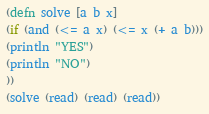<code> <loc_0><loc_0><loc_500><loc_500><_Clojure_>(defn solve [a b x]
(if (and (<= a x) (<= x (+ a b)))
(println "YES")
(println "NO")
))
(solve (read) (read) (read))
</code> 